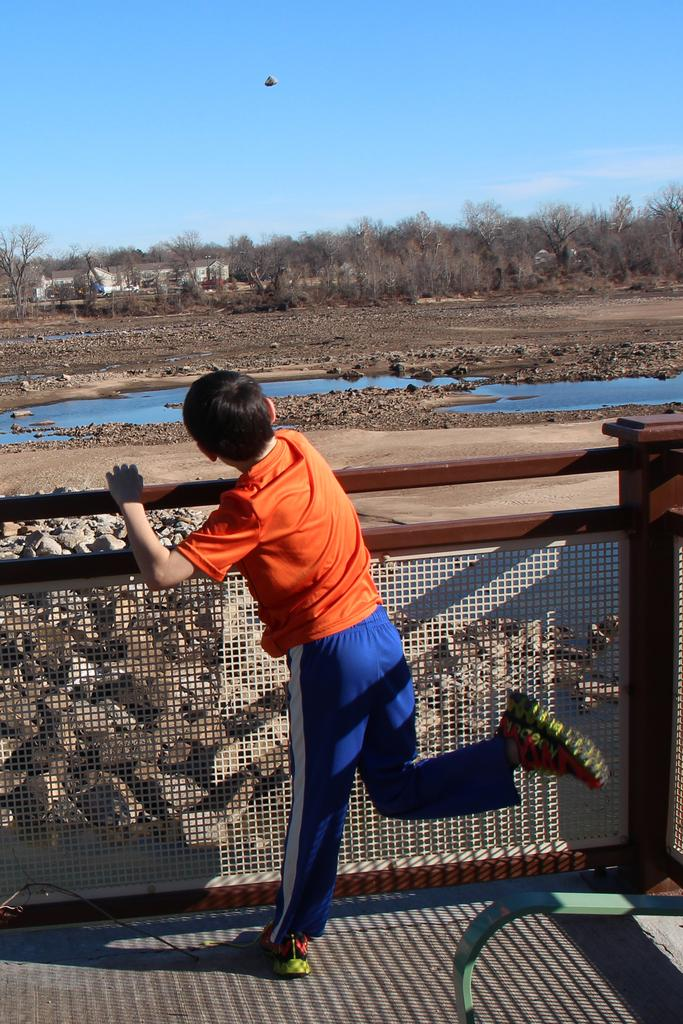What is the boy doing in the image? The boy is standing near the railing in the image. What can be seen in the middle of the image? There is water in the middle of the image. What type of vegetation is visible in the background of the image? There are trees in the background of the image. What is visible at the top of the image? The sky is visible at the top of the image. Can you tell me how many yaks are swimming in the water in the image? There are no yaks present in the image; it features a boy standing near the railing and water in the middle. What type of vegetable is growing near the trees in the image? There is no vegetable growing near the trees in the image; only trees are visible in the background. 